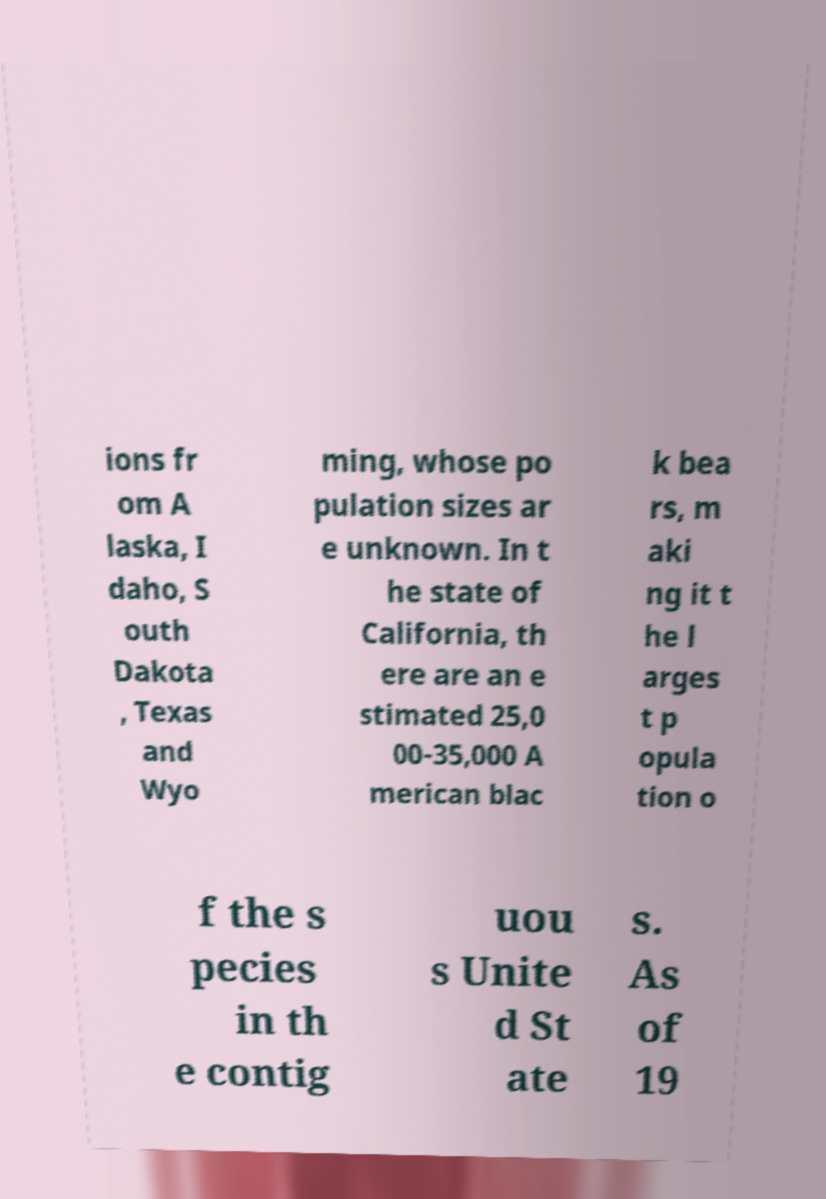What messages or text are displayed in this image? I need them in a readable, typed format. ions fr om A laska, I daho, S outh Dakota , Texas and Wyo ming, whose po pulation sizes ar e unknown. In t he state of California, th ere are an e stimated 25,0 00-35,000 A merican blac k bea rs, m aki ng it t he l arges t p opula tion o f the s pecies in th e contig uou s Unite d St ate s. As of 19 